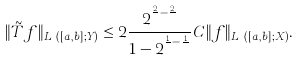<formula> <loc_0><loc_0><loc_500><loc_500>\| \tilde { T } f \| _ { L ^ { q } ( [ a , b ] ; Y ) } \leq 2 \frac { 2 ^ { \frac { 2 } { q } - \frac { 2 } { p } } } { 1 - 2 ^ { \frac { 1 } { q } - \frac { 1 } { p } } } C \| f \| _ { L ^ { p } ( [ a , b ] ; X ) } .</formula> 